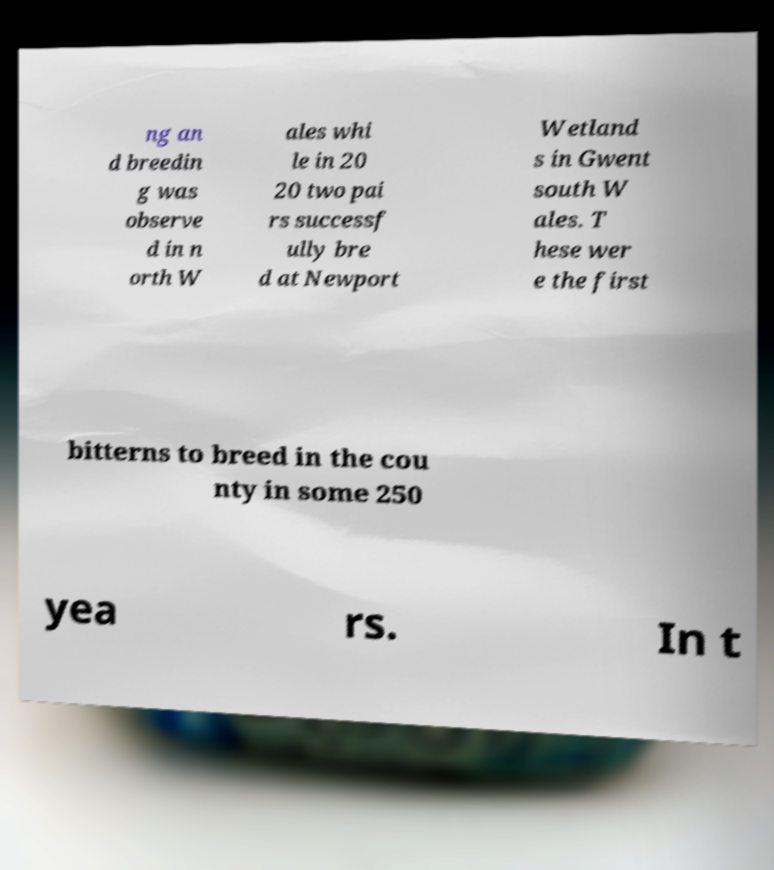Could you assist in decoding the text presented in this image and type it out clearly? ng an d breedin g was observe d in n orth W ales whi le in 20 20 two pai rs successf ully bre d at Newport Wetland s in Gwent south W ales. T hese wer e the first bitterns to breed in the cou nty in some 250 yea rs. In t 